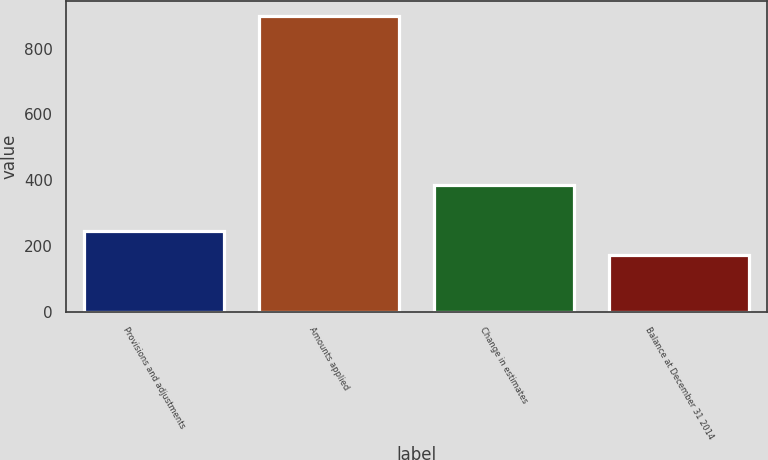Convert chart to OTSL. <chart><loc_0><loc_0><loc_500><loc_500><bar_chart><fcel>Provisions and adjustments<fcel>Amounts applied<fcel>Change in estimates<fcel>Balance at December 31 2014<nl><fcel>245.7<fcel>900<fcel>387<fcel>173<nl></chart> 